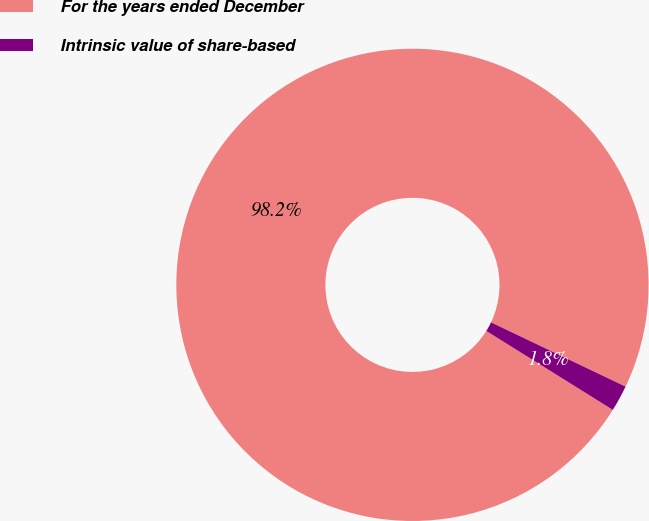<chart> <loc_0><loc_0><loc_500><loc_500><pie_chart><fcel>For the years ended December<fcel>Intrinsic value of share-based<nl><fcel>98.21%<fcel>1.79%<nl></chart> 